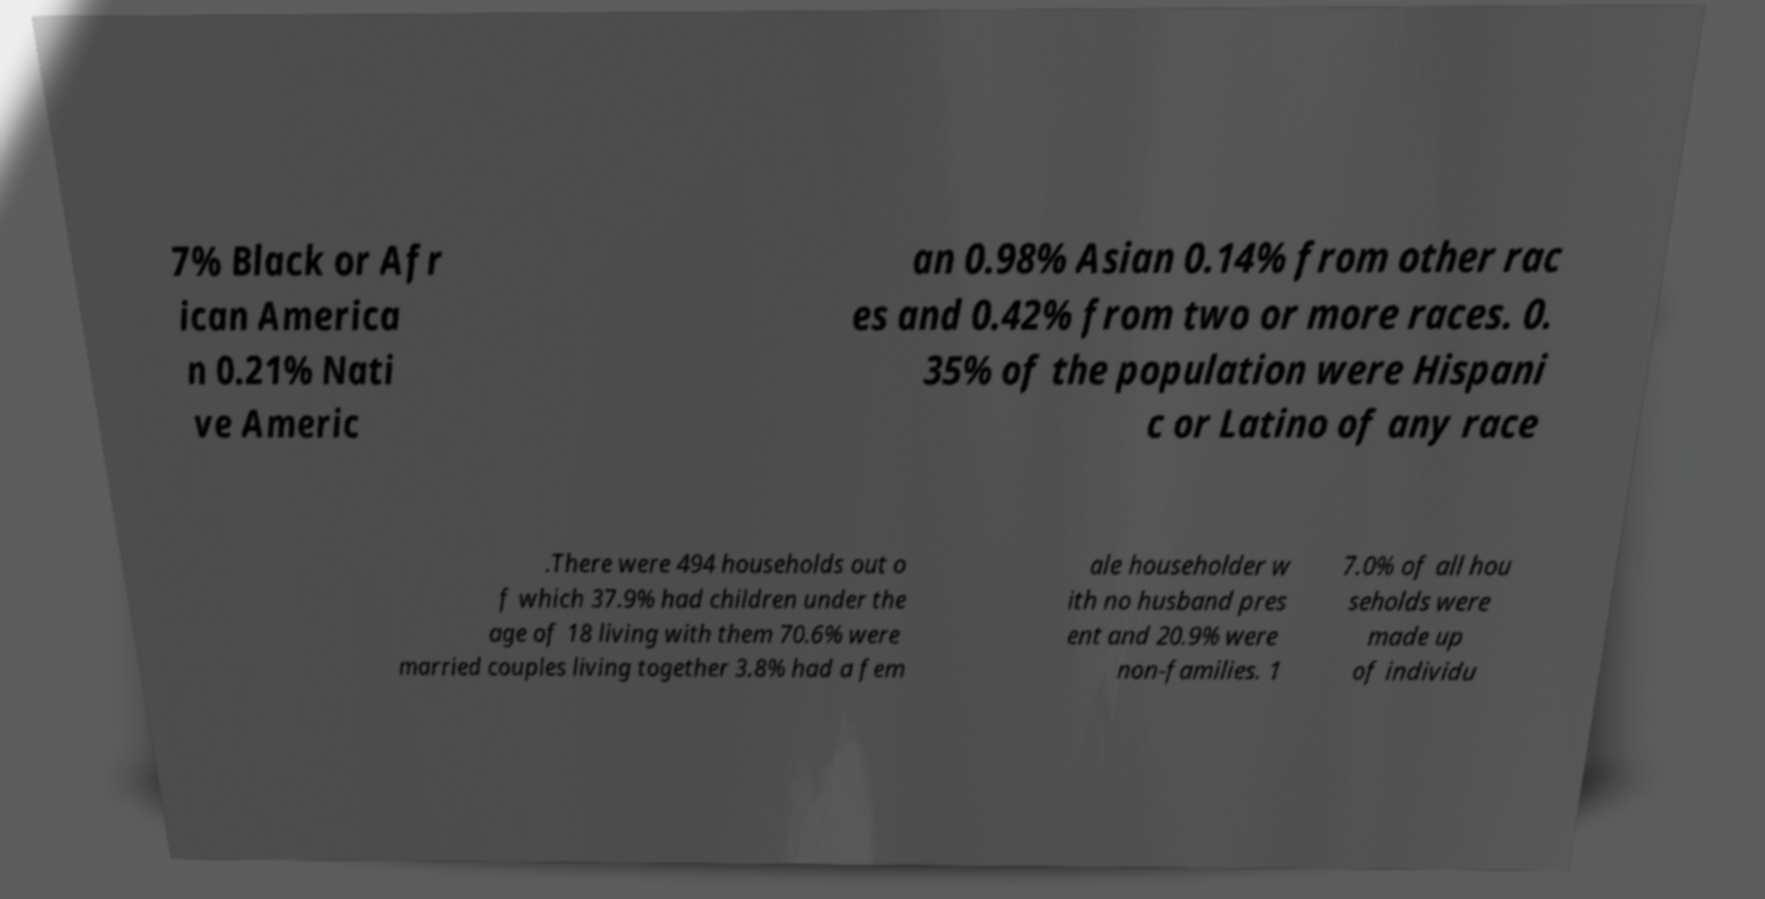For documentation purposes, I need the text within this image transcribed. Could you provide that? 7% Black or Afr ican America n 0.21% Nati ve Americ an 0.98% Asian 0.14% from other rac es and 0.42% from two or more races. 0. 35% of the population were Hispani c or Latino of any race .There were 494 households out o f which 37.9% had children under the age of 18 living with them 70.6% were married couples living together 3.8% had a fem ale householder w ith no husband pres ent and 20.9% were non-families. 1 7.0% of all hou seholds were made up of individu 